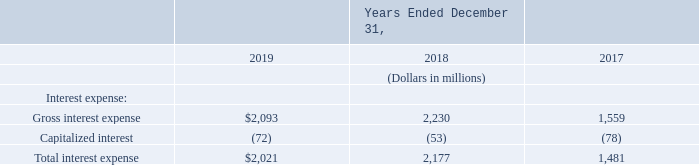Interest Expense
Interest expense includes interest on total long-term debt. The following table presents the amount of gross interest expense, net of capitalized interest:
What does interest expense include? Interest on total long-term debt. What is the total interest expense in 2019?
Answer scale should be: million. $2,021. What segments of interest expense are presented in the table? Gross interest expense, capitalized interest. Which year has the largest total interest expense? 2,177>2,021>1,481
Answer: 2018. What is the change in the gross interest expense in 2019 from 2018?
Answer scale should be: million. 2,093-2,230
Answer: -137. What is the average total interest expense for 2017 to 2019?
Answer scale should be: million. (2,021+2,177+1,481)/3
Answer: 1893. 